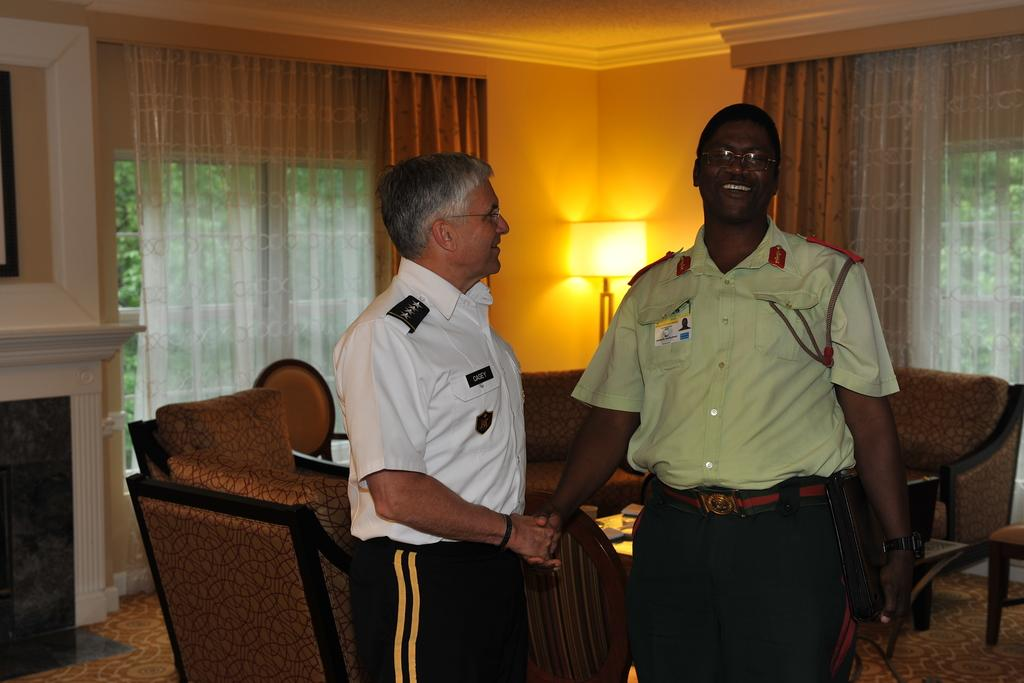Where was the image taken? The image was taken inside a room. What can be seen in the middle of the room? There are two persons standing, a sofa, curtains, and a lamp in the middle of the room. Can you tell me how many times the persons in the image laughed during the photoshoot? There is no information about laughter or a photoshoot in the image, so it cannot be determined. 